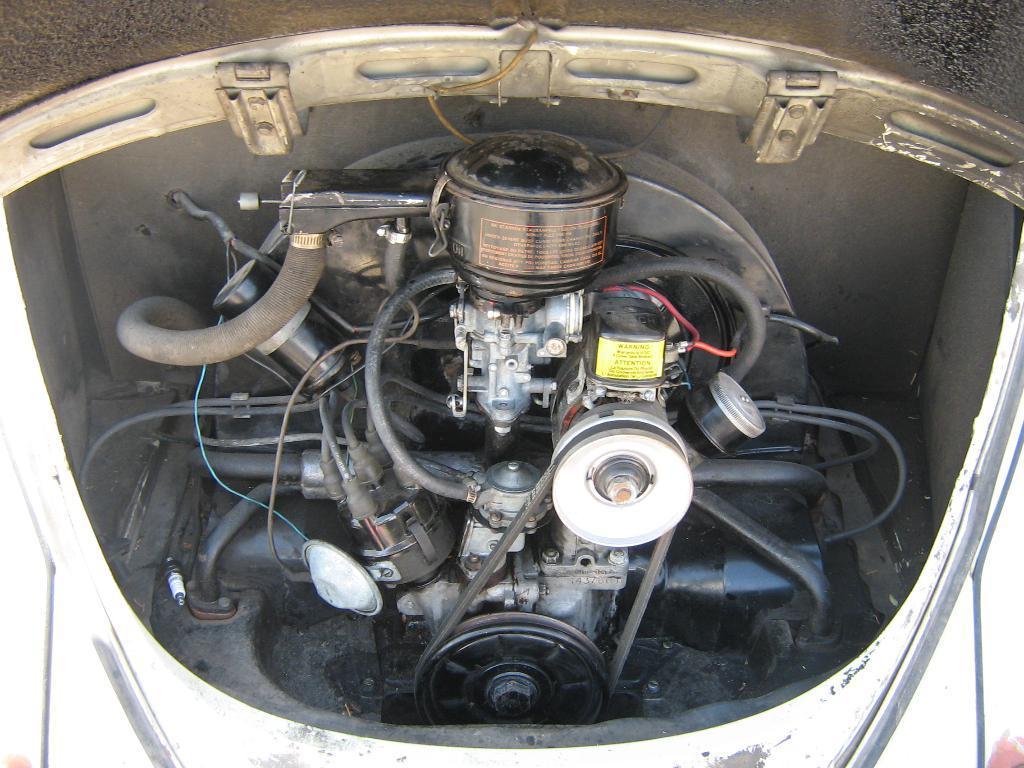Can you describe this image briefly? In the picture I can see an engine part of a vehicle. 